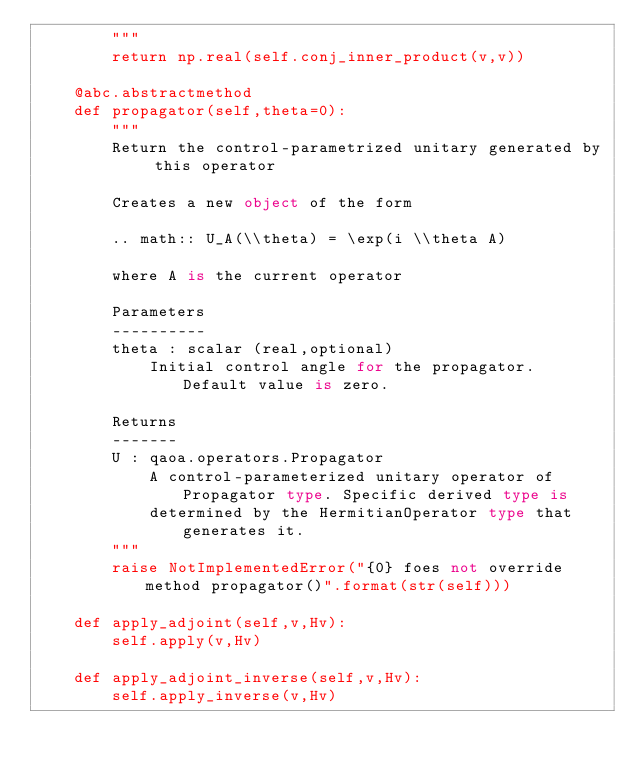<code> <loc_0><loc_0><loc_500><loc_500><_Python_>        """
        return np.real(self.conj_inner_product(v,v))

    @abc.abstractmethod
    def propagator(self,theta=0):
        """
        Return the control-parametrized unitary generated by this operator

        Creates a new object of the form 
  
        .. math:: U_A(\\theta) = \exp(i \\theta A)

        where A is the current operator

        Parameters
        ----------
        theta : scalar (real,optional)
            Initial control angle for the propagator. Default value is zero.
 
        Returns
        -------
        U : qaoa.operators.Propagator
            A control-parameterized unitary operator of Propagator type. Specific derived type is 
            determined by the HermitianOperator type that generates it.
        """
        raise NotImplementedError("{0} foes not override method propagator()".format(str(self)))

    def apply_adjoint(self,v,Hv):
        self.apply(v,Hv)

    def apply_adjoint_inverse(self,v,Hv):
        self.apply_inverse(v,Hv)


</code> 